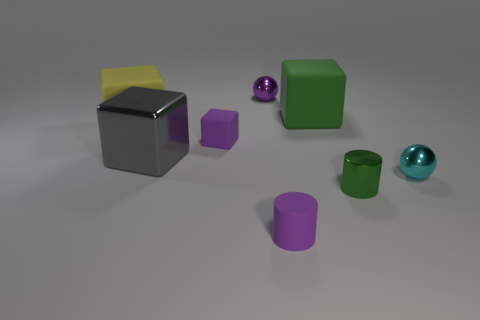The thing that is behind the purple rubber cylinder and in front of the cyan sphere has what shape?
Make the answer very short. Cylinder. What is the color of the tiny cylinder in front of the cylinder that is right of the block to the right of the purple shiny object?
Your answer should be compact. Purple. Are there more large yellow rubber things that are behind the small purple shiny sphere than green objects on the right side of the tiny shiny cylinder?
Offer a very short reply. No. How many other objects are there of the same size as the purple sphere?
Offer a terse response. 4. There is a metal sphere that is the same color as the small matte block; what size is it?
Your answer should be compact. Small. There is a ball to the left of the big block behind the yellow block; what is its material?
Give a very brief answer. Metal. There is a purple metal sphere; are there any rubber blocks to the right of it?
Your answer should be very brief. Yes. Is the number of big green objects that are to the left of the small matte cylinder greater than the number of large red metallic cubes?
Give a very brief answer. No. Is there a tiny matte cylinder that has the same color as the tiny metal cylinder?
Make the answer very short. No. What is the color of the matte cylinder that is the same size as the green metal cylinder?
Provide a short and direct response. Purple. 